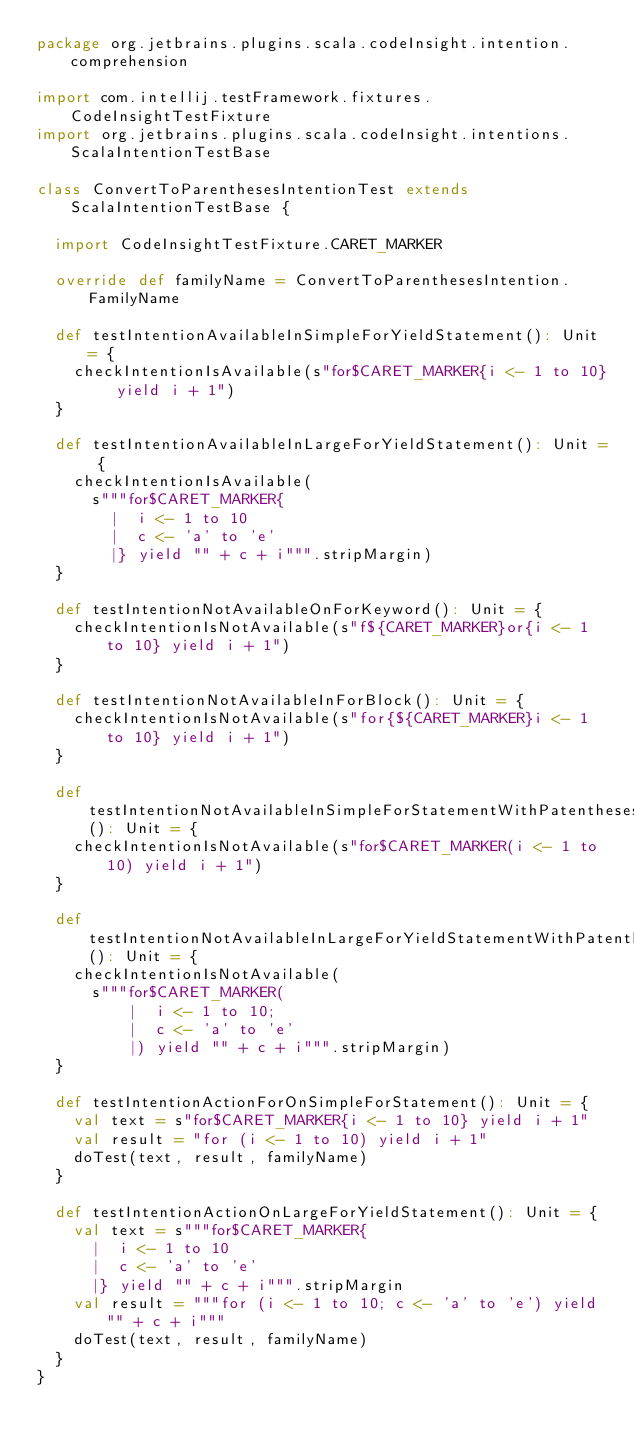<code> <loc_0><loc_0><loc_500><loc_500><_Scala_>package org.jetbrains.plugins.scala.codeInsight.intention.comprehension

import com.intellij.testFramework.fixtures.CodeInsightTestFixture
import org.jetbrains.plugins.scala.codeInsight.intentions.ScalaIntentionTestBase

class ConvertToParenthesesIntentionTest extends ScalaIntentionTestBase {

  import CodeInsightTestFixture.CARET_MARKER

  override def familyName = ConvertToParenthesesIntention.FamilyName

  def testIntentionAvailableInSimpleForYieldStatement(): Unit = {
    checkIntentionIsAvailable(s"for$CARET_MARKER{i <- 1 to 10} yield i + 1")
  }

  def testIntentionAvailableInLargeForYieldStatement(): Unit = {
    checkIntentionIsAvailable(
      s"""for$CARET_MARKER{
        |  i <- 1 to 10
        |  c <- 'a' to 'e'
        |} yield "" + c + i""".stripMargin)
  }

  def testIntentionNotAvailableOnForKeyword(): Unit = {
    checkIntentionIsNotAvailable(s"f${CARET_MARKER}or{i <- 1 to 10} yield i + 1")
  }

  def testIntentionNotAvailableInForBlock(): Unit = {
    checkIntentionIsNotAvailable(s"for{${CARET_MARKER}i <- 1 to 10} yield i + 1")
  }

  def testIntentionNotAvailableInSimpleForStatementWithPatentheses(): Unit = {
    checkIntentionIsNotAvailable(s"for$CARET_MARKER(i <- 1 to 10) yield i + 1")
  }

  def testIntentionNotAvailableInLargeForYieldStatementWithPatentheses(): Unit = {
    checkIntentionIsNotAvailable(
      s"""for$CARET_MARKER(
          |  i <- 1 to 10;
          |  c <- 'a' to 'e'
          |) yield "" + c + i""".stripMargin)
  }

  def testIntentionActionForOnSimpleForStatement(): Unit = {
    val text = s"for$CARET_MARKER{i <- 1 to 10} yield i + 1"
    val result = "for (i <- 1 to 10) yield i + 1"
    doTest(text, result, familyName)
  }

  def testIntentionActionOnLargeForYieldStatement(): Unit = {
    val text = s"""for$CARET_MARKER{
      |  i <- 1 to 10
      |  c <- 'a' to 'e'
      |} yield "" + c + i""".stripMargin
    val result = """for (i <- 1 to 10; c <- 'a' to 'e') yield "" + c + i"""
    doTest(text, result, familyName)
  }
}</code> 